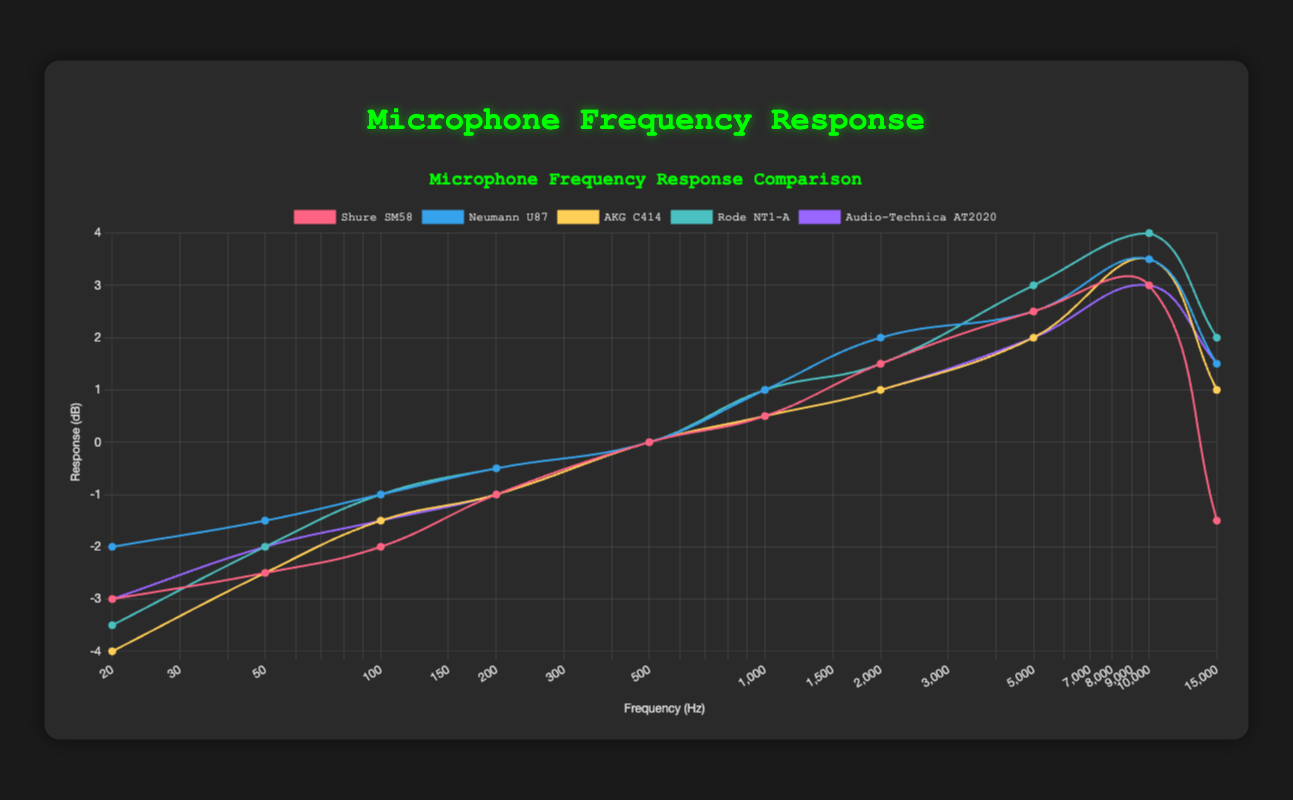What is the highest frequency response value displayed by the Rode NT1-A microphone, and at what frequency does it occur? To find this, you need to look at the line representing the Rode NT1-A. The highest response value reaches 4.0 dB, which occurs at 10,000 Hz.
Answer: 4.0 dB at 10,000 Hz Which microphone has the flattest response from 500 Hz to 1,000 Hz? Scan the lines for each microphone within the frequency range of 500 Hz to 1,000 Hz. The Audio-Technica AT2020 has a very flat response, staying at 0.5 dB in this range.
Answer: Audio-Technica AT2020 At 2 kHz, which microphone shows the highest response value? Check the response values of all microphones at 2kHz. The Neumann U87 shows the highest response value at 2.0 dB.
Answer: Neumann U87 How does the response of the Shure SM58 at 500 Hz compare to its response at 10,000 Hz? Observe the Shure SM58 response values at 500 Hz and 10,000 Hz. At 500 Hz, the response is 0.0 dB, and at 10,000 Hz, it is 3.0 dB, thus an increase of 3 dB.
Answer: Increase of 3 dB Which microphone has the largest decline in response from 10,000 Hz to 15,000 Hz? Examine the response values for each microphone at 10,000 Hz and 15,000 Hz, then calculate the difference. The Shure SM58 declines from 3.0 dB to -1.5 dB, the largest drop of 4.5 dB.
Answer: Shure SM58 What is the average response value for the AKG C414 between 50 Hz and 500 Hz? Calculate the average response from the values at 50 Hz, 100 Hz, 200 Hz, and 500 Hz. (-2.5 + -1.5 + -1.0 + 0.0) / 4 = -1.25 dB.
Answer: -1.25 dB Which microphone's response curve is represented by the red line? Observing the color associated with each microphone's line, the red line corresponds to the frequency response of the Shure SM58.
Answer: Shure SM58 Between 1 kHz and 5 kHz, which microphone shows the most consistent increase in response? Tracking the changes in response values from 1 kHz to 5 kHz for each microphone, the Rode NT1-A consistently increases from 1.0 dB to 3.0 dB.
Answer: Rode NT1-A By how much does the response of the Neumann U87 change from 1 kHz to 15 kHz? The response starts at 1.0 dB at 1 kHz and increases to 1.5 dB at 15 kHz, resulting in a change of 0.5 dB.
Answer: 0.5 dB 